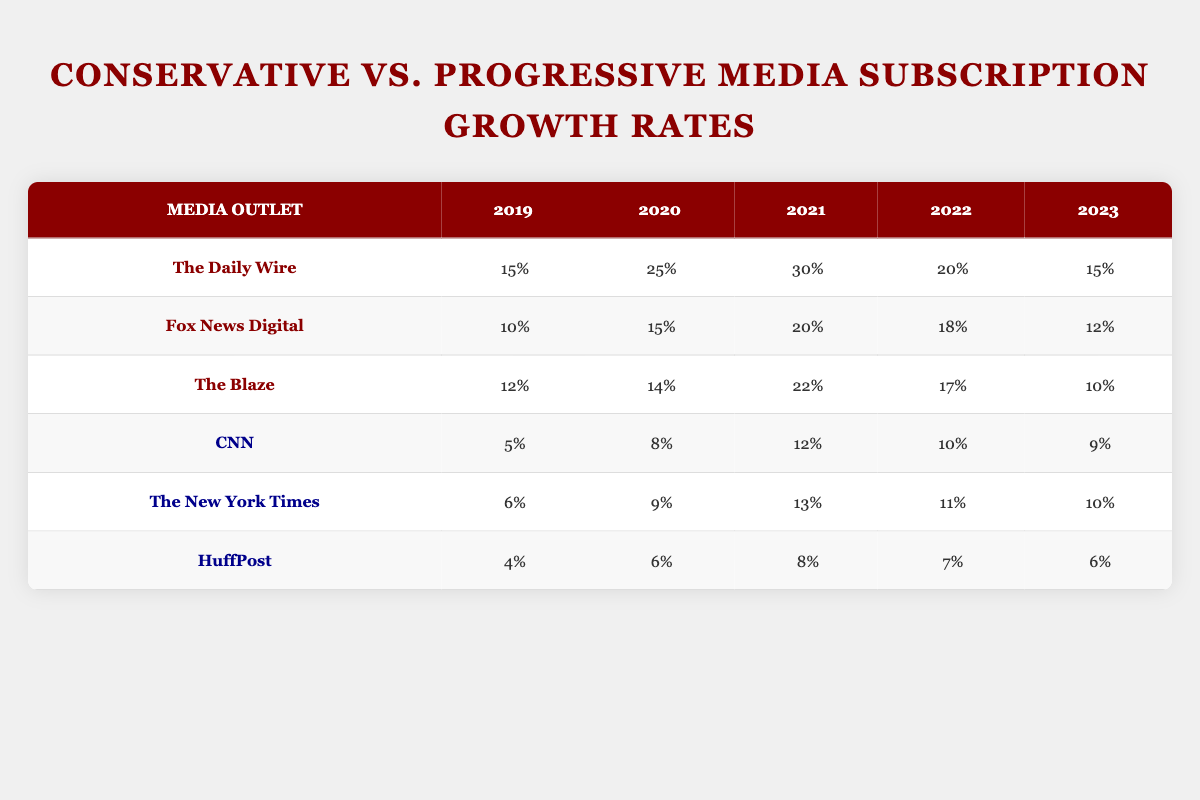What was the growth rate for The Daily Wire in 2021? The table shows a specific value for The Daily Wire under the 2021 column, which is 30%.
Answer: 30% Which outlet had the highest subscription growth rate in 2020? In reviewing the 2020 column for all media outlets, The Daily Wire has the highest growth rate listed at 25%.
Answer: The Daily Wire What is the average subscription growth rate for conservative media outlets over the years? The conservative outlets are The Daily Wire, Fox News Digital, and The Blaze. Their growth rates summed over 2019-2023 are (15 + 25 + 30 + 20 + 15) + (10 + 15 + 20 + 18 + 12) + (12 + 14 + 22 + 17 + 10) = 85 + 75 + 85 = 245. There are 15 total values (5 years × 3 outlets), so the average is 245/15 = 16.33.
Answer: 16.33 Did HuffPost ever exceed a 10% growth rate in any year? By looking at the growth rates for HuffPost, the highest figure is 8% in 2021, and it did not exceed 10% in any year as it remained below that mark.
Answer: No What is the difference in subscription growth rates between CNN in 2019 and 2023? For CNN, the growth rate in 2019 is 5% and in 2023 it is 9%. The difference is calculated by subtracting the earlier year's rate (5) from the later year's rate (9), resulting in 9 - 5 = 4%.
Answer: 4% Which progressive outlet had the most consistent growth rate from 2019 to 2023? Examining the growth rates for CNN, The New York Times, and HuffPost, CNN shows a gradual increase each year until a slight decrease in 2022, while the other two had more fluctuations. This suggests CNN had the most consistent growth trend during the specified years.
Answer: CNN What was the maximum growth rate achieved by Fox News Digital between 2019 and 2023? By reviewing the growth rates for Fox News Digital in the table, we see that it peaked at 20% in 2021, after which it declined.
Answer: 20% How many times did The Blaze have a growth rate below 15% from 2019 to 2023? Analyzing The Blaze's growth rates, it registered below 15% in 2019 (12%), 2023 (10%), and also in 2020 (14%). This indicates three instances of being below 15%.
Answer: 3 